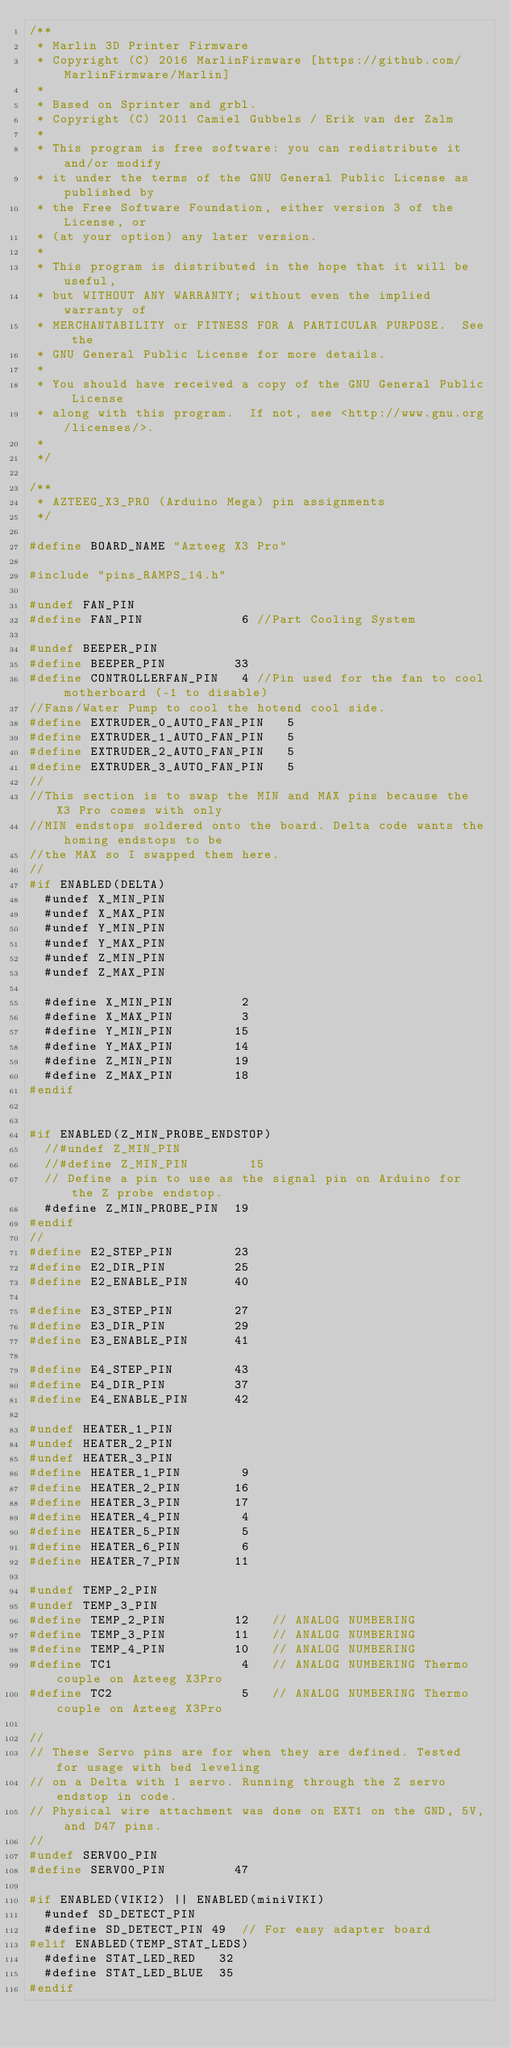Convert code to text. <code><loc_0><loc_0><loc_500><loc_500><_C_>/**
 * Marlin 3D Printer Firmware
 * Copyright (C) 2016 MarlinFirmware [https://github.com/MarlinFirmware/Marlin]
 *
 * Based on Sprinter and grbl.
 * Copyright (C) 2011 Camiel Gubbels / Erik van der Zalm
 *
 * This program is free software: you can redistribute it and/or modify
 * it under the terms of the GNU General Public License as published by
 * the Free Software Foundation, either version 3 of the License, or
 * (at your option) any later version.
 *
 * This program is distributed in the hope that it will be useful,
 * but WITHOUT ANY WARRANTY; without even the implied warranty of
 * MERCHANTABILITY or FITNESS FOR A PARTICULAR PURPOSE.  See the
 * GNU General Public License for more details.
 *
 * You should have received a copy of the GNU General Public License
 * along with this program.  If not, see <http://www.gnu.org/licenses/>.
 *
 */

/**
 * AZTEEG_X3_PRO (Arduino Mega) pin assignments
 */

#define BOARD_NAME "Azteeg X3 Pro"

#include "pins_RAMPS_14.h"

#undef FAN_PIN
#define FAN_PIN             6 //Part Cooling System

#undef BEEPER_PIN
#define BEEPER_PIN         33
#define CONTROLLERFAN_PIN   4 //Pin used for the fan to cool motherboard (-1 to disable)
//Fans/Water Pump to cool the hotend cool side.
#define EXTRUDER_0_AUTO_FAN_PIN   5
#define EXTRUDER_1_AUTO_FAN_PIN   5
#define EXTRUDER_2_AUTO_FAN_PIN   5
#define EXTRUDER_3_AUTO_FAN_PIN   5
//
//This section is to swap the MIN and MAX pins because the X3 Pro comes with only
//MIN endstops soldered onto the board. Delta code wants the homing endstops to be
//the MAX so I swapped them here.
//
#if ENABLED(DELTA)
  #undef X_MIN_PIN
  #undef X_MAX_PIN
  #undef Y_MIN_PIN
  #undef Y_MAX_PIN
  #undef Z_MIN_PIN
  #undef Z_MAX_PIN

  #define X_MIN_PIN         2
  #define X_MAX_PIN         3
  #define Y_MIN_PIN        15
  #define Y_MAX_PIN        14
  #define Z_MIN_PIN        19
  #define Z_MAX_PIN        18
#endif


#if ENABLED(Z_MIN_PROBE_ENDSTOP)
  //#undef Z_MIN_PIN
  //#define Z_MIN_PIN        15
  // Define a pin to use as the signal pin on Arduino for the Z probe endstop.
  #define Z_MIN_PROBE_PIN  19
#endif
//
#define E2_STEP_PIN        23
#define E2_DIR_PIN         25
#define E2_ENABLE_PIN      40

#define E3_STEP_PIN        27
#define E3_DIR_PIN         29
#define E3_ENABLE_PIN      41

#define E4_STEP_PIN        43
#define E4_DIR_PIN         37
#define E4_ENABLE_PIN      42

#undef HEATER_1_PIN
#undef HEATER_2_PIN
#undef HEATER_3_PIN
#define HEATER_1_PIN        9
#define HEATER_2_PIN       16
#define HEATER_3_PIN       17
#define HEATER_4_PIN        4
#define HEATER_5_PIN        5
#define HEATER_6_PIN        6
#define HEATER_7_PIN       11

#undef TEMP_2_PIN
#undef TEMP_3_PIN
#define TEMP_2_PIN         12   // ANALOG NUMBERING
#define TEMP_3_PIN         11   // ANALOG NUMBERING
#define TEMP_4_PIN         10   // ANALOG NUMBERING
#define TC1                 4   // ANALOG NUMBERING Thermo couple on Azteeg X3Pro
#define TC2                 5   // ANALOG NUMBERING Thermo couple on Azteeg X3Pro

//
// These Servo pins are for when they are defined. Tested for usage with bed leveling
// on a Delta with 1 servo. Running through the Z servo endstop in code.
// Physical wire attachment was done on EXT1 on the GND, 5V, and D47 pins.
//
#undef SERVO0_PIN
#define SERVO0_PIN         47

#if ENABLED(VIKI2) || ENABLED(miniVIKI)
  #undef SD_DETECT_PIN
  #define SD_DETECT_PIN 49  // For easy adapter board
#elif ENABLED(TEMP_STAT_LEDS)
  #define STAT_LED_RED   32
  #define STAT_LED_BLUE  35
#endif
</code> 